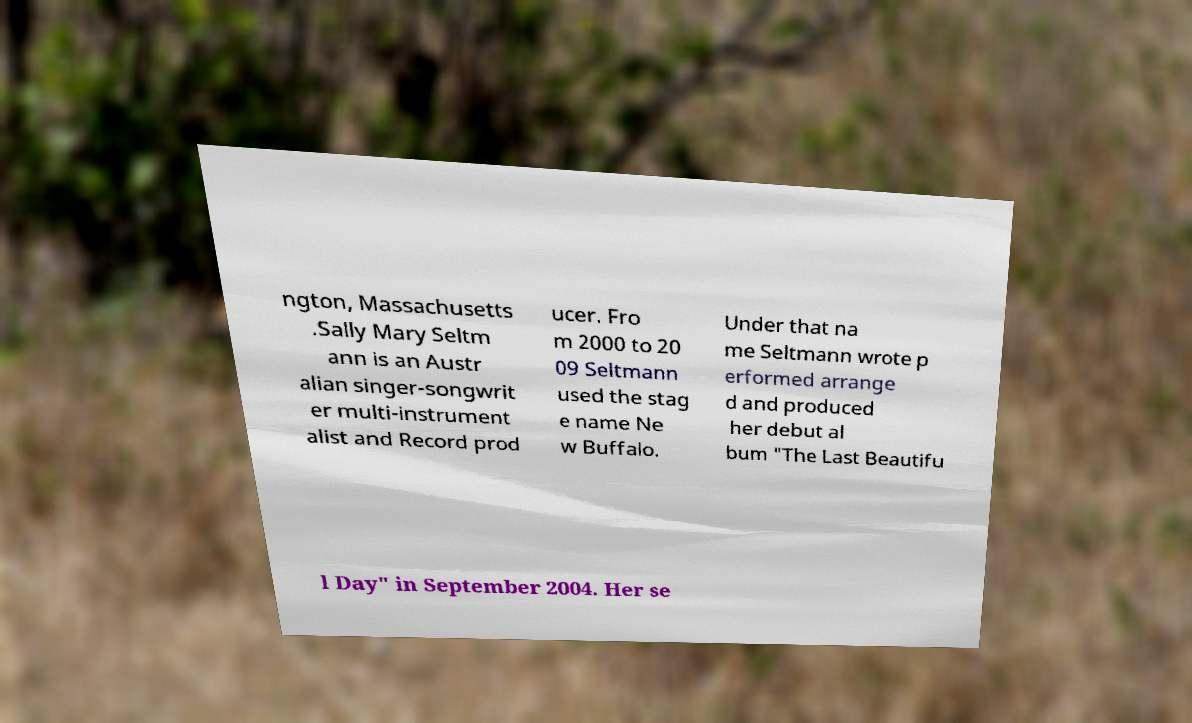Can you read and provide the text displayed in the image?This photo seems to have some interesting text. Can you extract and type it out for me? ngton, Massachusetts .Sally Mary Seltm ann is an Austr alian singer-songwrit er multi-instrument alist and Record prod ucer. Fro m 2000 to 20 09 Seltmann used the stag e name Ne w Buffalo. Under that na me Seltmann wrote p erformed arrange d and produced her debut al bum "The Last Beautifu l Day" in September 2004. Her se 